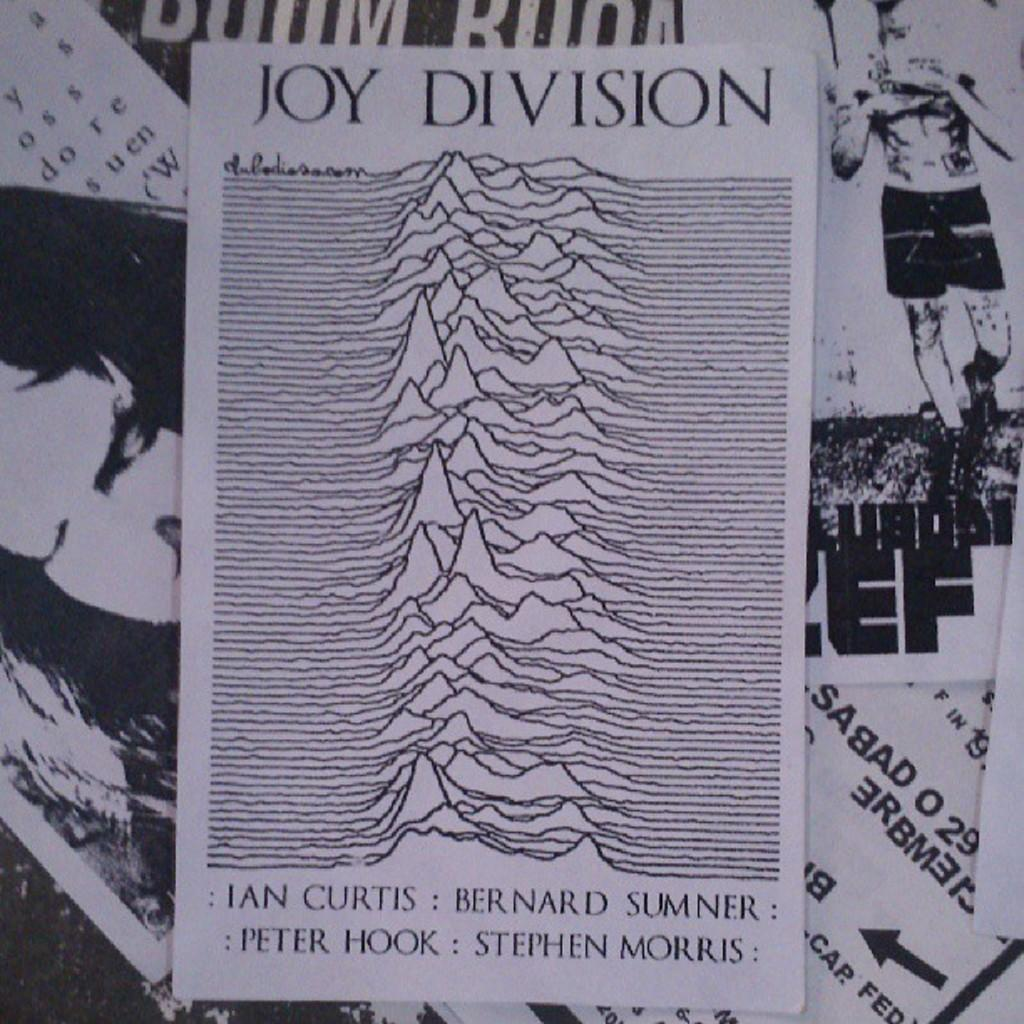<image>
Offer a succinct explanation of the picture presented. A closeup of the vinyl art for Joy Division which features their names 